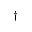Convert formula to latex. <formula><loc_0><loc_0><loc_500><loc_500>{ \dag }</formula> 